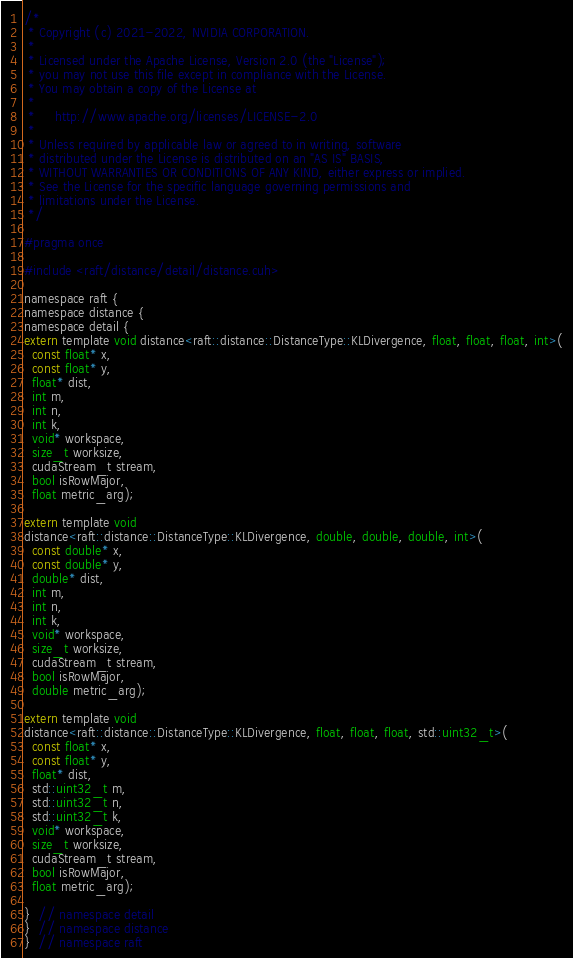<code> <loc_0><loc_0><loc_500><loc_500><_Cuda_>/*
 * Copyright (c) 2021-2022, NVIDIA CORPORATION.
 *
 * Licensed under the Apache License, Version 2.0 (the "License");
 * you may not use this file except in compliance with the License.
 * You may obtain a copy of the License at
 *
 *     http://www.apache.org/licenses/LICENSE-2.0
 *
 * Unless required by applicable law or agreed to in writing, software
 * distributed under the License is distributed on an "AS IS" BASIS,
 * WITHOUT WARRANTIES OR CONDITIONS OF ANY KIND, either express or implied.
 * See the License for the specific language governing permissions and
 * limitations under the License.
 */

#pragma once

#include <raft/distance/detail/distance.cuh>

namespace raft {
namespace distance {
namespace detail {
extern template void distance<raft::distance::DistanceType::KLDivergence, float, float, float, int>(
  const float* x,
  const float* y,
  float* dist,
  int m,
  int n,
  int k,
  void* workspace,
  size_t worksize,
  cudaStream_t stream,
  bool isRowMajor,
  float metric_arg);

extern template void
distance<raft::distance::DistanceType::KLDivergence, double, double, double, int>(
  const double* x,
  const double* y,
  double* dist,
  int m,
  int n,
  int k,
  void* workspace,
  size_t worksize,
  cudaStream_t stream,
  bool isRowMajor,
  double metric_arg);

extern template void
distance<raft::distance::DistanceType::KLDivergence, float, float, float, std::uint32_t>(
  const float* x,
  const float* y,
  float* dist,
  std::uint32_t m,
  std::uint32_t n,
  std::uint32_t k,
  void* workspace,
  size_t worksize,
  cudaStream_t stream,
  bool isRowMajor,
  float metric_arg);

}  // namespace detail
}  // namespace distance
}  // namespace raft
</code> 